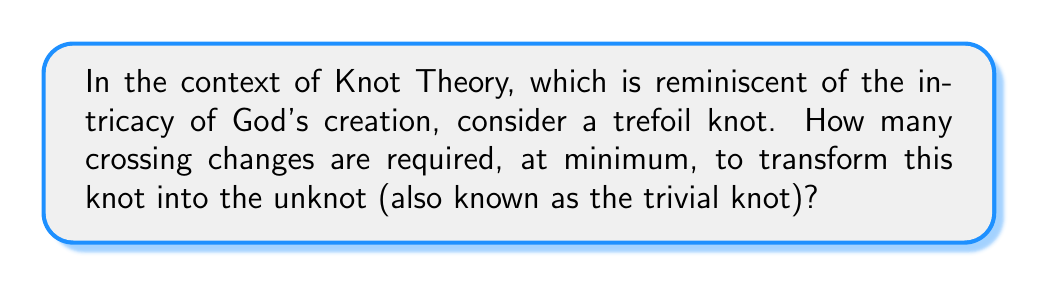Teach me how to tackle this problem. To determine the unknotting number of a trefoil knot, we can follow these steps:

1. Understand the trefoil knot:
   The trefoil knot is the simplest non-trivial knot, represented by the knot diagram with three crossings.

2. Define unknotting number:
   The unknotting number is the minimum number of crossing changes required to transform a knot into the unknot.

3. Analyze the trefoil knot:
   - The trefoil knot has a crossing number of 3.
   - It is a prime knot, meaning it cannot be decomposed into simpler knots.

4. Consider possible unknotting sequences:
   - Changing one crossing: This results in another trefoil knot (with opposite chirality), not the unknot.
   - Changing two crossings: This can result in the unknot.

5. Prove minimality:
   - The unknotting number is always less than or equal to the crossing number.
   - The trefoil knot is non-trivial, so its unknotting number must be at least 1.
   - We've shown that 2 crossing changes are sufficient.
   - The algebraic proof involves the concept of knot signature:
     The signature of a trefoil knot is $\sigma(T) = \pm 2$, and each crossing change can alter the signature by at most 2.
     Therefore, at least $|\sigma(T)|/2 = 1$ crossing change is needed.

6. Conclusion:
   The unknotting number of the trefoil knot is 1, as it requires exactly one crossing change to transform it into the unknot.
Answer: 1 